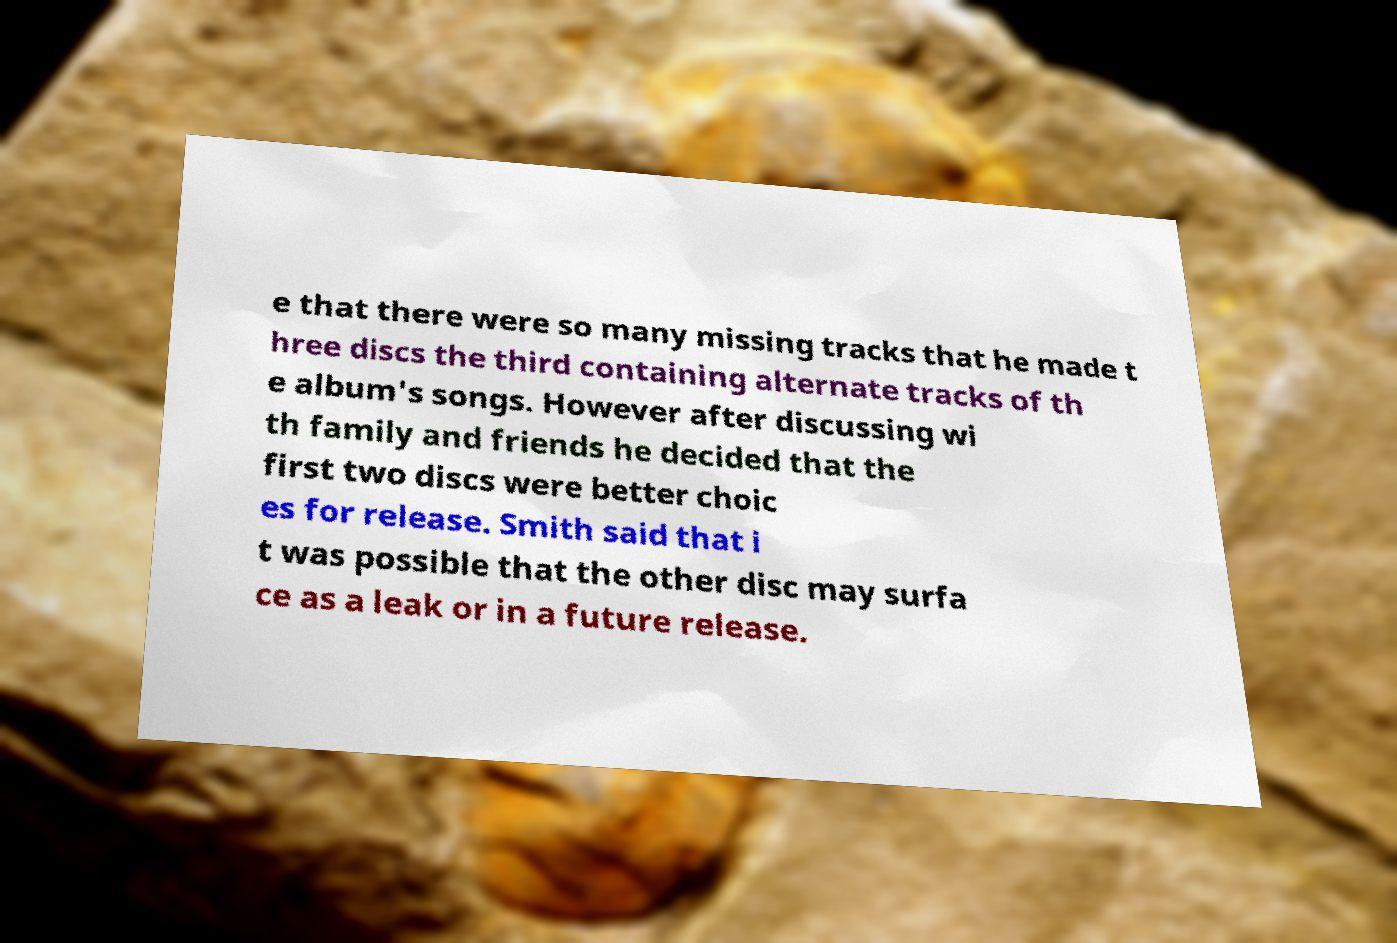Can you accurately transcribe the text from the provided image for me? e that there were so many missing tracks that he made t hree discs the third containing alternate tracks of th e album's songs. However after discussing wi th family and friends he decided that the first two discs were better choic es for release. Smith said that i t was possible that the other disc may surfa ce as a leak or in a future release. 